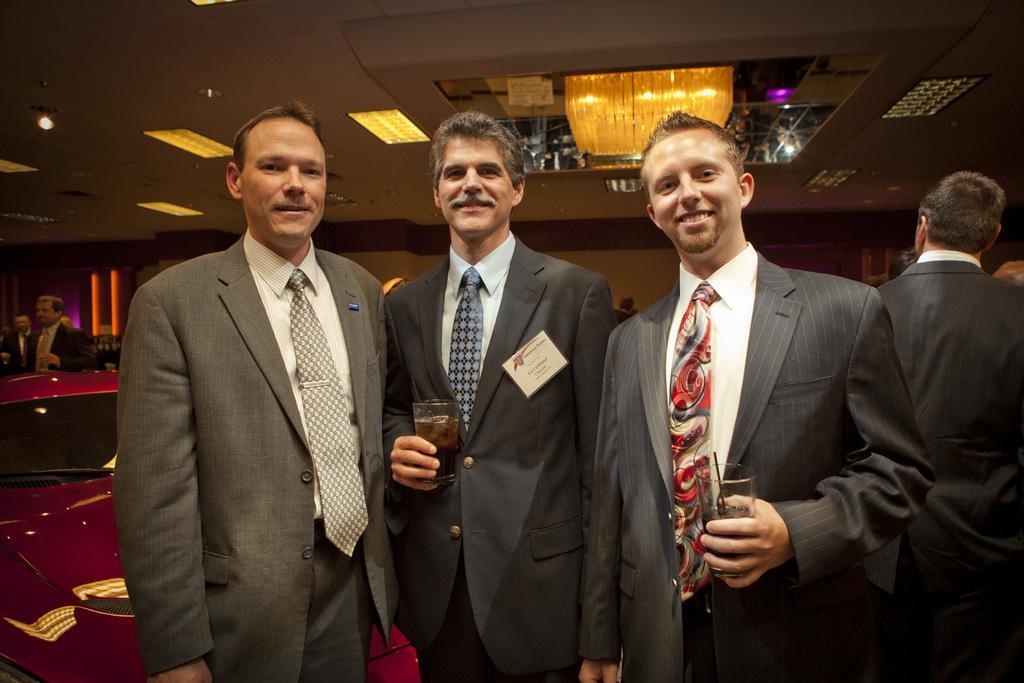Could you give a brief overview of what you see in this image? This picture shows few people standing and we see couple of men holding glasses in their hands and we see a smile on their faces and few lights on the roof and and men wore ties on their neck. 